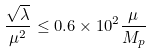<formula> <loc_0><loc_0><loc_500><loc_500>\frac { \sqrt { \lambda } } { \mu ^ { 2 } } \leq 0 . 6 \times 1 0 ^ { 2 } \frac { \mu } { M _ { p } }</formula> 